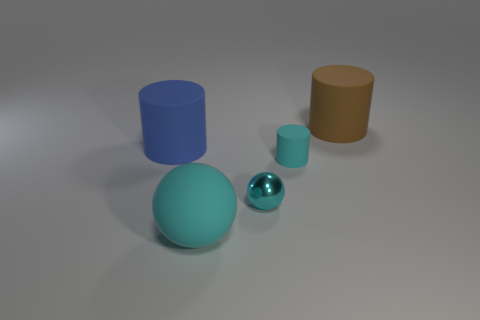What number of small things are shiny spheres or yellow metallic blocks?
Offer a very short reply. 1. Are there any other things that are the same color as the tiny cylinder?
Provide a succinct answer. Yes. There is a tiny object that is the same material as the large blue object; what is its shape?
Provide a short and direct response. Cylinder. How big is the matte cylinder behind the blue rubber cylinder?
Ensure brevity in your answer.  Large. What is the shape of the big blue thing?
Your answer should be compact. Cylinder. There is a rubber cylinder to the right of the tiny cyan cylinder; does it have the same size as the cyan ball that is in front of the metal thing?
Your answer should be very brief. Yes. There is a matte object that is behind the big cylinder that is left of the big object that is to the right of the big sphere; what size is it?
Provide a short and direct response. Large. There is a thing that is behind the cylinder that is left of the cylinder in front of the blue matte object; what is its shape?
Keep it short and to the point. Cylinder. There is a rubber thing in front of the tiny ball; what is its shape?
Give a very brief answer. Sphere. Are the large blue cylinder and the small thing behind the tiny ball made of the same material?
Make the answer very short. Yes. 